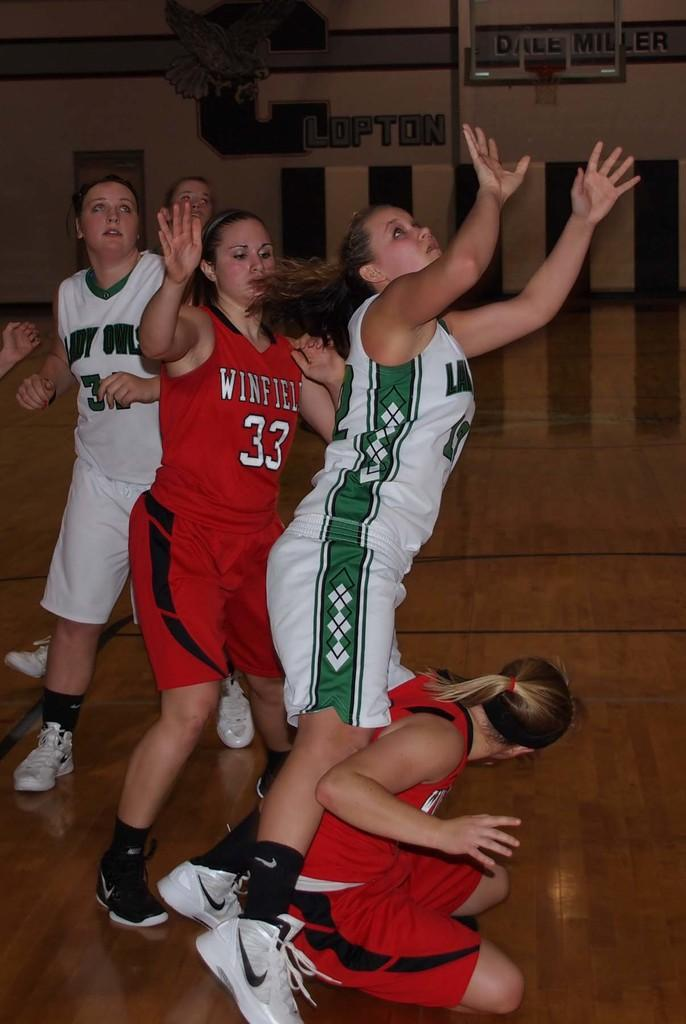<image>
Offer a succinct explanation of the picture presented. Female basketball players from the Lady Owls and Winfield teams jostle for the ball in the gym.s 